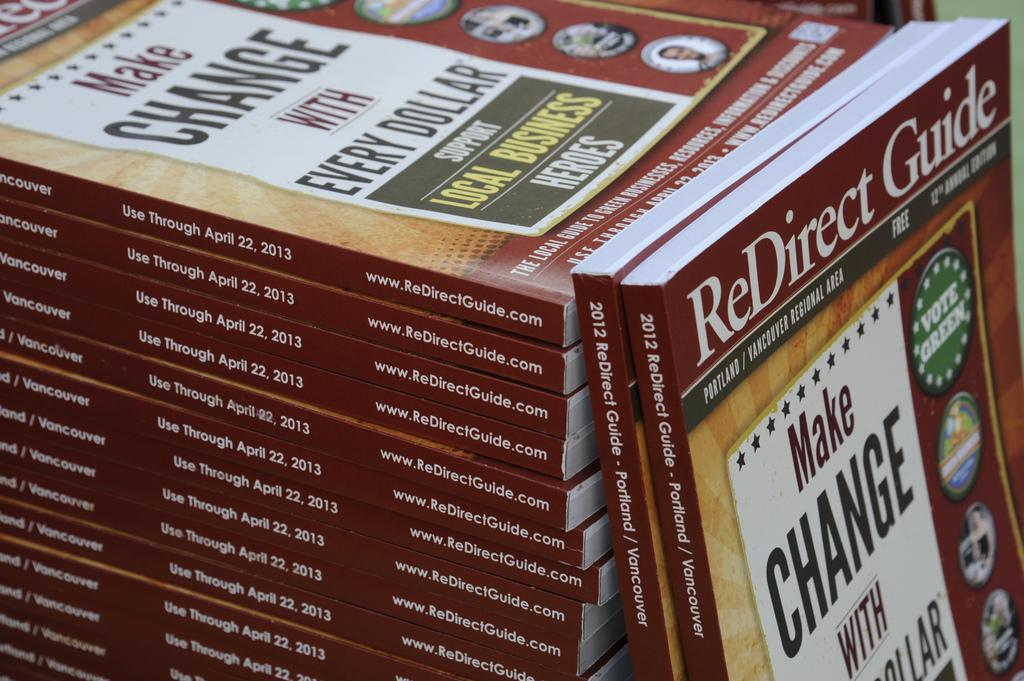Provide a one-sentence caption for the provided image. A stack of the Redirect Guide is from 2012. 